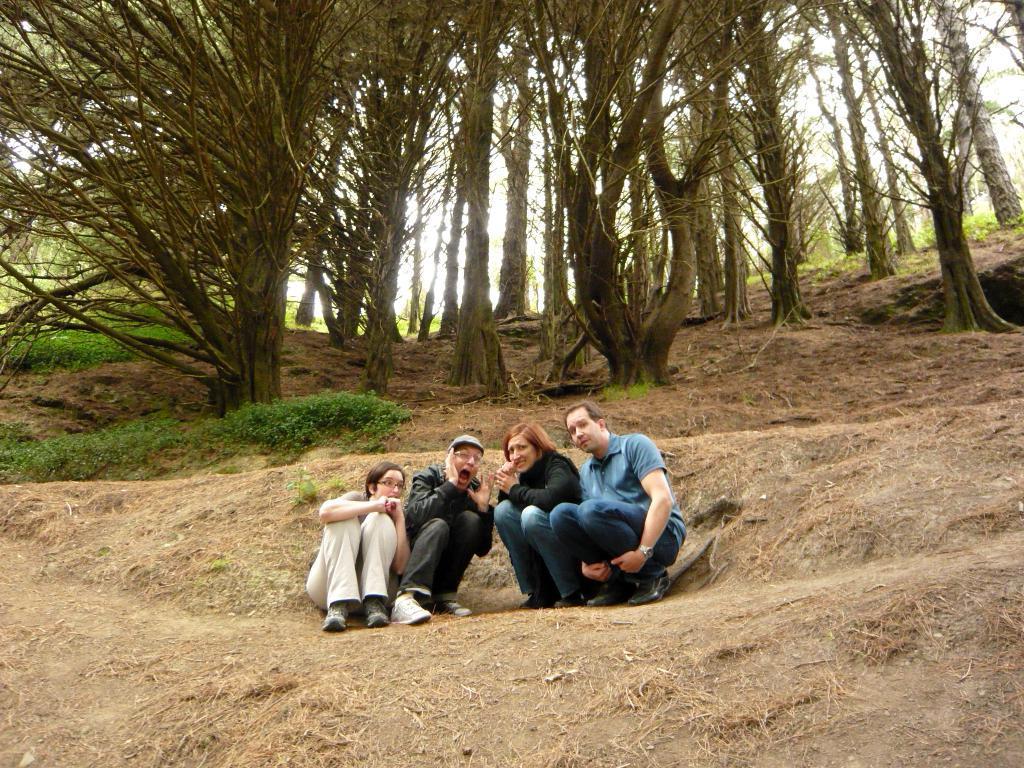Please provide a concise description of this image. In this picture we can see four people. We can see some dry grass on the ground. There are a few plants and trees are visible in the background. 